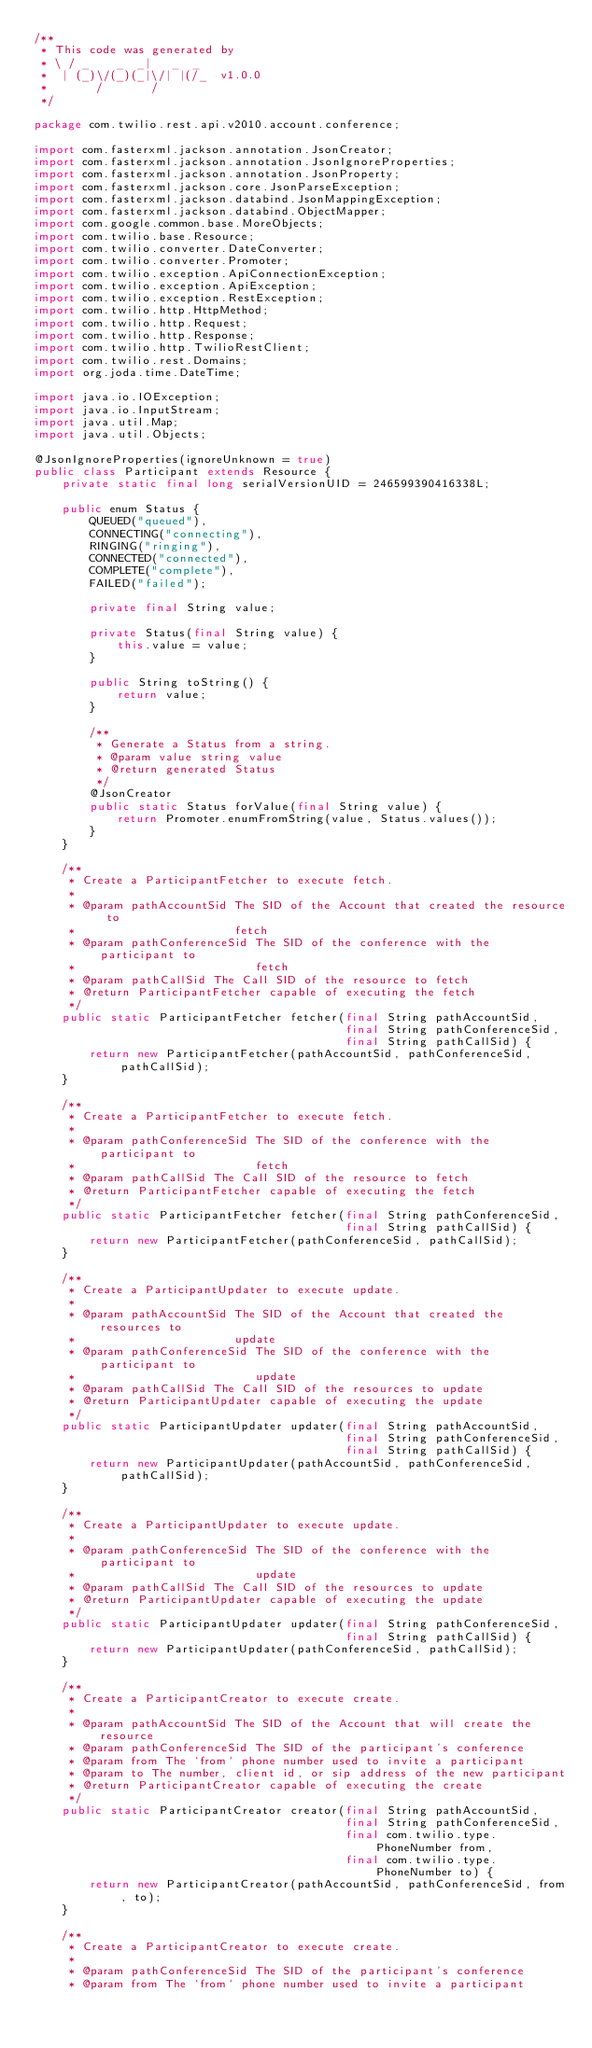Convert code to text. <code><loc_0><loc_0><loc_500><loc_500><_Java_>/**
 * This code was generated by
 * \ / _    _  _|   _  _
 *  | (_)\/(_)(_|\/| |(/_  v1.0.0
 *       /       /
 */

package com.twilio.rest.api.v2010.account.conference;

import com.fasterxml.jackson.annotation.JsonCreator;
import com.fasterxml.jackson.annotation.JsonIgnoreProperties;
import com.fasterxml.jackson.annotation.JsonProperty;
import com.fasterxml.jackson.core.JsonParseException;
import com.fasterxml.jackson.databind.JsonMappingException;
import com.fasterxml.jackson.databind.ObjectMapper;
import com.google.common.base.MoreObjects;
import com.twilio.base.Resource;
import com.twilio.converter.DateConverter;
import com.twilio.converter.Promoter;
import com.twilio.exception.ApiConnectionException;
import com.twilio.exception.ApiException;
import com.twilio.exception.RestException;
import com.twilio.http.HttpMethod;
import com.twilio.http.Request;
import com.twilio.http.Response;
import com.twilio.http.TwilioRestClient;
import com.twilio.rest.Domains;
import org.joda.time.DateTime;

import java.io.IOException;
import java.io.InputStream;
import java.util.Map;
import java.util.Objects;

@JsonIgnoreProperties(ignoreUnknown = true)
public class Participant extends Resource {
    private static final long serialVersionUID = 246599390416338L;

    public enum Status {
        QUEUED("queued"),
        CONNECTING("connecting"),
        RINGING("ringing"),
        CONNECTED("connected"),
        COMPLETE("complete"),
        FAILED("failed");

        private final String value;

        private Status(final String value) {
            this.value = value;
        }

        public String toString() {
            return value;
        }

        /**
         * Generate a Status from a string.
         * @param value string value
         * @return generated Status
         */
        @JsonCreator
        public static Status forValue(final String value) {
            return Promoter.enumFromString(value, Status.values());
        }
    }

    /**
     * Create a ParticipantFetcher to execute fetch.
     * 
     * @param pathAccountSid The SID of the Account that created the resource to
     *                       fetch
     * @param pathConferenceSid The SID of the conference with the participant to
     *                          fetch
     * @param pathCallSid The Call SID of the resource to fetch
     * @return ParticipantFetcher capable of executing the fetch
     */
    public static ParticipantFetcher fetcher(final String pathAccountSid, 
                                             final String pathConferenceSid, 
                                             final String pathCallSid) {
        return new ParticipantFetcher(pathAccountSid, pathConferenceSid, pathCallSid);
    }

    /**
     * Create a ParticipantFetcher to execute fetch.
     * 
     * @param pathConferenceSid The SID of the conference with the participant to
     *                          fetch
     * @param pathCallSid The Call SID of the resource to fetch
     * @return ParticipantFetcher capable of executing the fetch
     */
    public static ParticipantFetcher fetcher(final String pathConferenceSid, 
                                             final String pathCallSid) {
        return new ParticipantFetcher(pathConferenceSid, pathCallSid);
    }

    /**
     * Create a ParticipantUpdater to execute update.
     * 
     * @param pathAccountSid The SID of the Account that created the resources to
     *                       update
     * @param pathConferenceSid The SID of the conference with the participant to
     *                          update
     * @param pathCallSid The Call SID of the resources to update
     * @return ParticipantUpdater capable of executing the update
     */
    public static ParticipantUpdater updater(final String pathAccountSid, 
                                             final String pathConferenceSid, 
                                             final String pathCallSid) {
        return new ParticipantUpdater(pathAccountSid, pathConferenceSid, pathCallSid);
    }

    /**
     * Create a ParticipantUpdater to execute update.
     * 
     * @param pathConferenceSid The SID of the conference with the participant to
     *                          update
     * @param pathCallSid The Call SID of the resources to update
     * @return ParticipantUpdater capable of executing the update
     */
    public static ParticipantUpdater updater(final String pathConferenceSid, 
                                             final String pathCallSid) {
        return new ParticipantUpdater(pathConferenceSid, pathCallSid);
    }

    /**
     * Create a ParticipantCreator to execute create.
     * 
     * @param pathAccountSid The SID of the Account that will create the resource
     * @param pathConferenceSid The SID of the participant's conference
     * @param from The `from` phone number used to invite a participant
     * @param to The number, client id, or sip address of the new participant
     * @return ParticipantCreator capable of executing the create
     */
    public static ParticipantCreator creator(final String pathAccountSid, 
                                             final String pathConferenceSid, 
                                             final com.twilio.type.PhoneNumber from, 
                                             final com.twilio.type.PhoneNumber to) {
        return new ParticipantCreator(pathAccountSid, pathConferenceSid, from, to);
    }

    /**
     * Create a ParticipantCreator to execute create.
     * 
     * @param pathConferenceSid The SID of the participant's conference
     * @param from The `from` phone number used to invite a participant</code> 